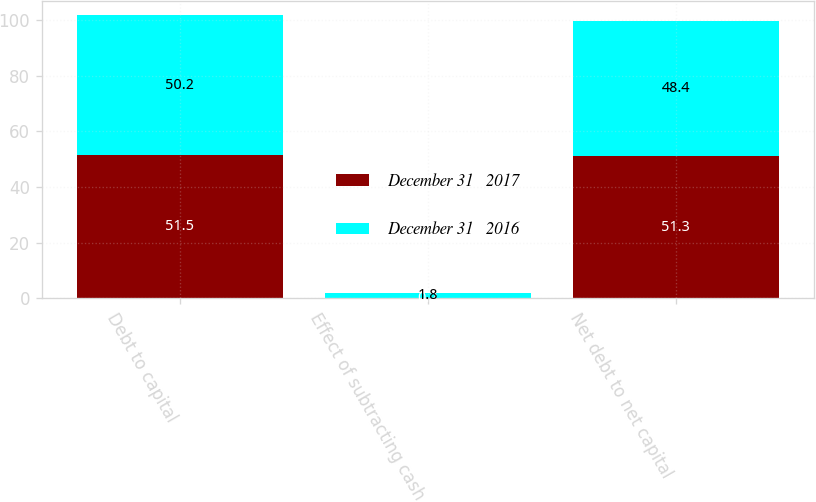<chart> <loc_0><loc_0><loc_500><loc_500><stacked_bar_chart><ecel><fcel>Debt to capital<fcel>Effect of subtracting cash<fcel>Net debt to net capital<nl><fcel>December 31   2017<fcel>51.5<fcel>0.2<fcel>51.3<nl><fcel>December 31   2016<fcel>50.2<fcel>1.8<fcel>48.4<nl></chart> 